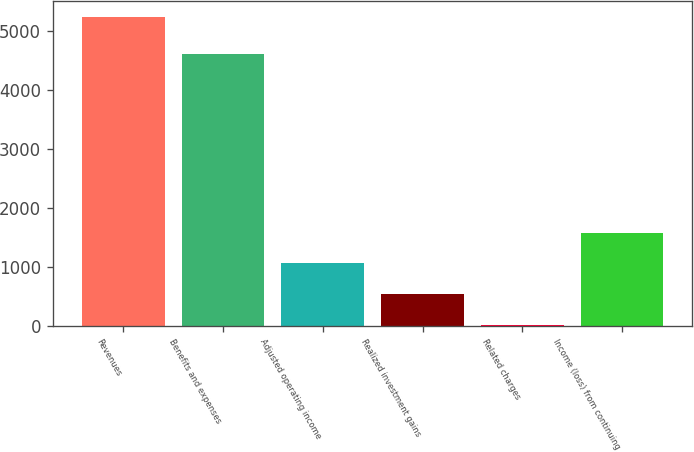Convert chart to OTSL. <chart><loc_0><loc_0><loc_500><loc_500><bar_chart><fcel>Revenues<fcel>Benefits and expenses<fcel>Adjusted operating income<fcel>Realized investment gains<fcel>Related charges<fcel>Income (loss) from continuing<nl><fcel>5233<fcel>4598<fcel>1053.8<fcel>531.4<fcel>9<fcel>1576.2<nl></chart> 